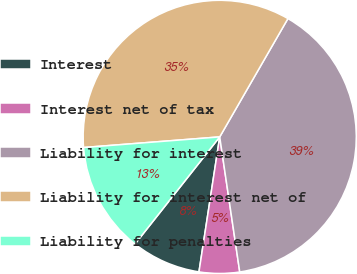Convert chart. <chart><loc_0><loc_0><loc_500><loc_500><pie_chart><fcel>Interest<fcel>Interest net of tax<fcel>Liability for interest<fcel>Liability for interest net of<fcel>Liability for penalties<nl><fcel>8.22%<fcel>4.77%<fcel>39.33%<fcel>34.56%<fcel>13.11%<nl></chart> 